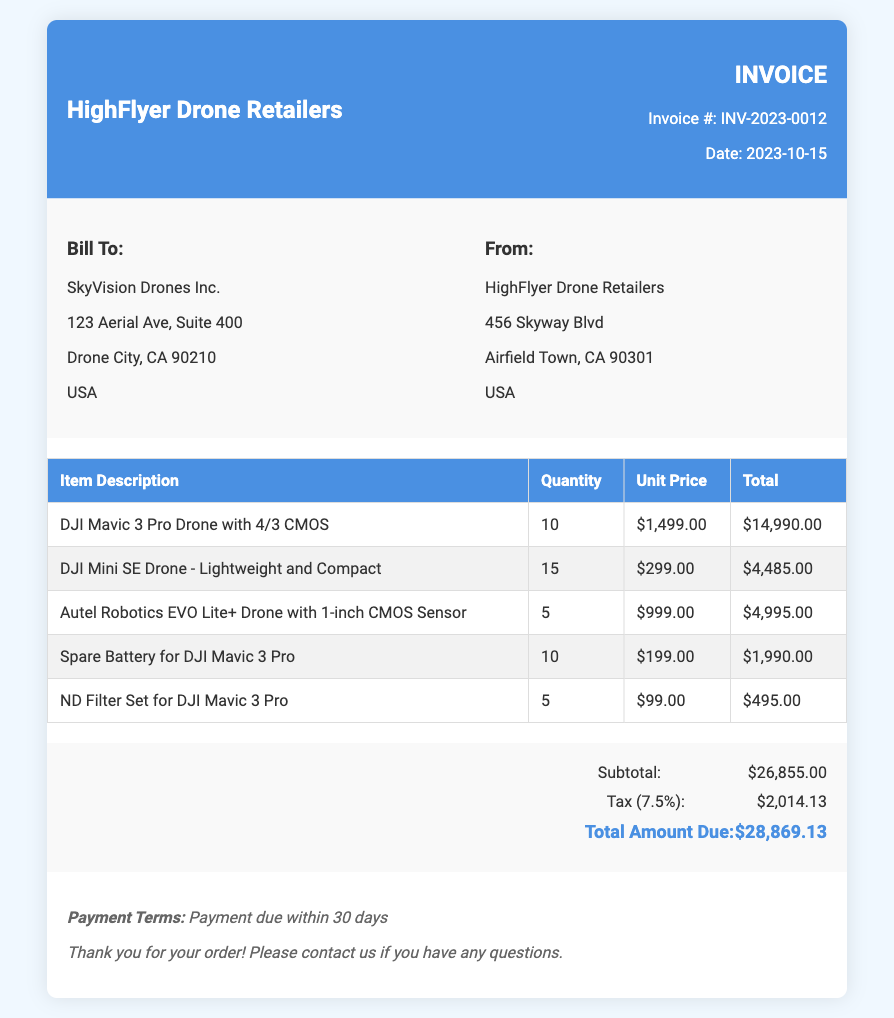what is the invoice number? The invoice number is specified under the invoice details section as INV-2023-0012.
Answer: INV-2023-0012 who is billed for this purchase? The bill to section indicates that SkyVision Drones Inc. is the customer being invoiced.
Answer: SkyVision Drones Inc what is the date of the invoice? The date is noted clearly in the invoice details, which is 2023-10-15.
Answer: 2023-10-15 how many DJI Mavic 3 Pro Drones were purchased? The quantity of DJI Mavic 3 Pro Drones is mentioned in the items table, which shows 10 units.
Answer: 10 what is the subtotal amount? The subtotal amount can be found in the summary section, which states the subtotal is $26,855.00.
Answer: $26,855.00 how much tax is applied to the invoice? The tax amount of 7.5% is calculated and presented in the summary section as $2,014.13.
Answer: $2,014.13 what is the total amount due? The total amount due is summarized at the end of the document as $28,869.13.
Answer: $28,869.13 how many different types of drones are listed in the invoice? The items table details three types of drones purchased, indicating the variety in the order.
Answer: 3 what are the payment terms stated in the invoice? The payment terms are explicitly mentioned at the bottom, stating payment due within 30 days.
Answer: Payment due within 30 days 